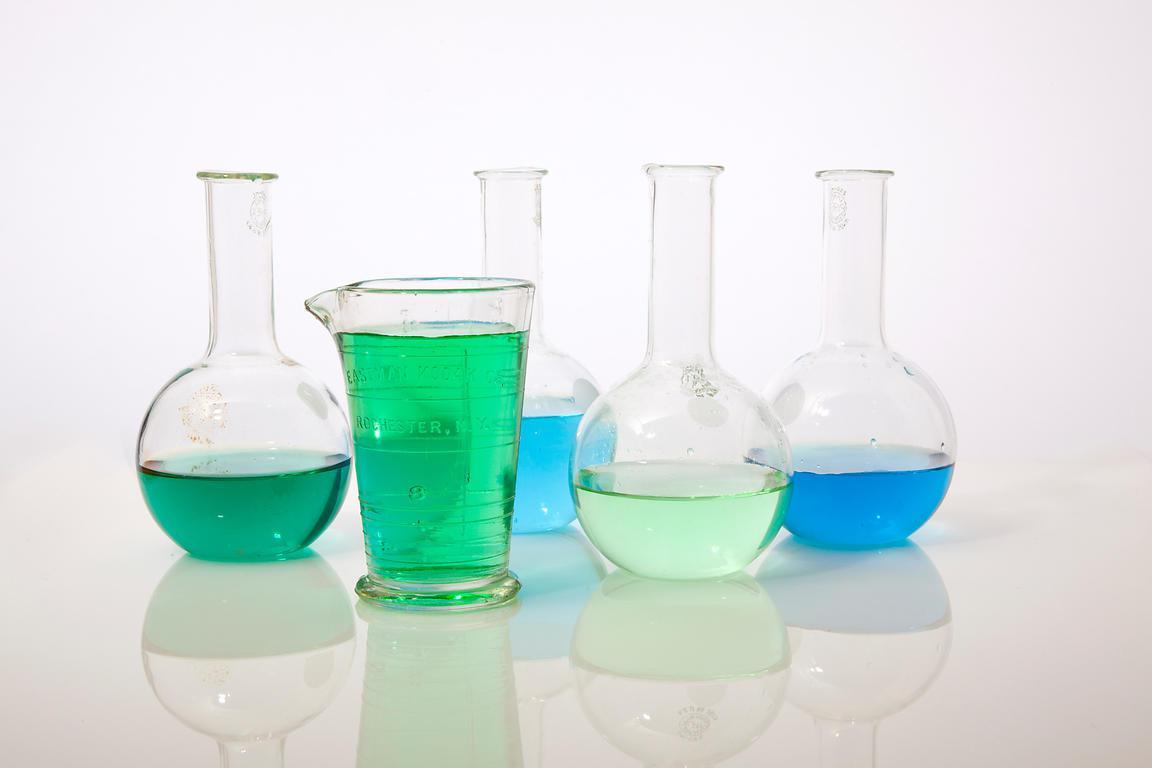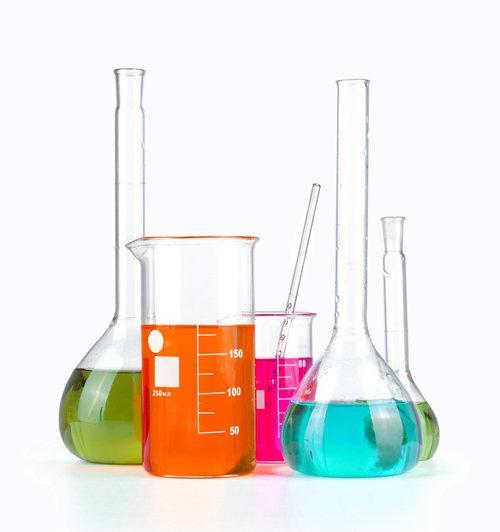The first image is the image on the left, the second image is the image on the right. Analyze the images presented: Is the assertion "The image on the right has at least 4 beakers." valid? Answer yes or no. Yes. The first image is the image on the left, the second image is the image on the right. Assess this claim about the two images: "There are less than nine containers.". Correct or not? Answer yes or no. No. 